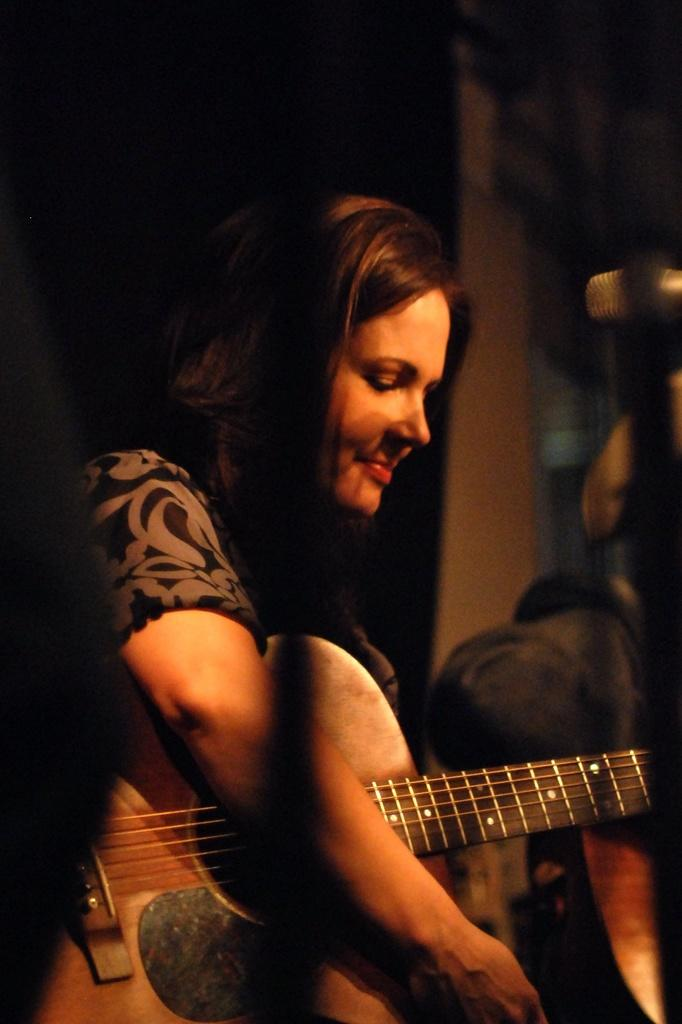Who is the main subject in the image? There is a woman in the image. What is the woman holding in the image? The woman is holding a guitar. What type of mint is the woman chewing in the image? There is no mint present in the image; the woman is holding a guitar. What type of drug is the woman using in the image? There is no drug present in the image; the woman is holding a guitar. 